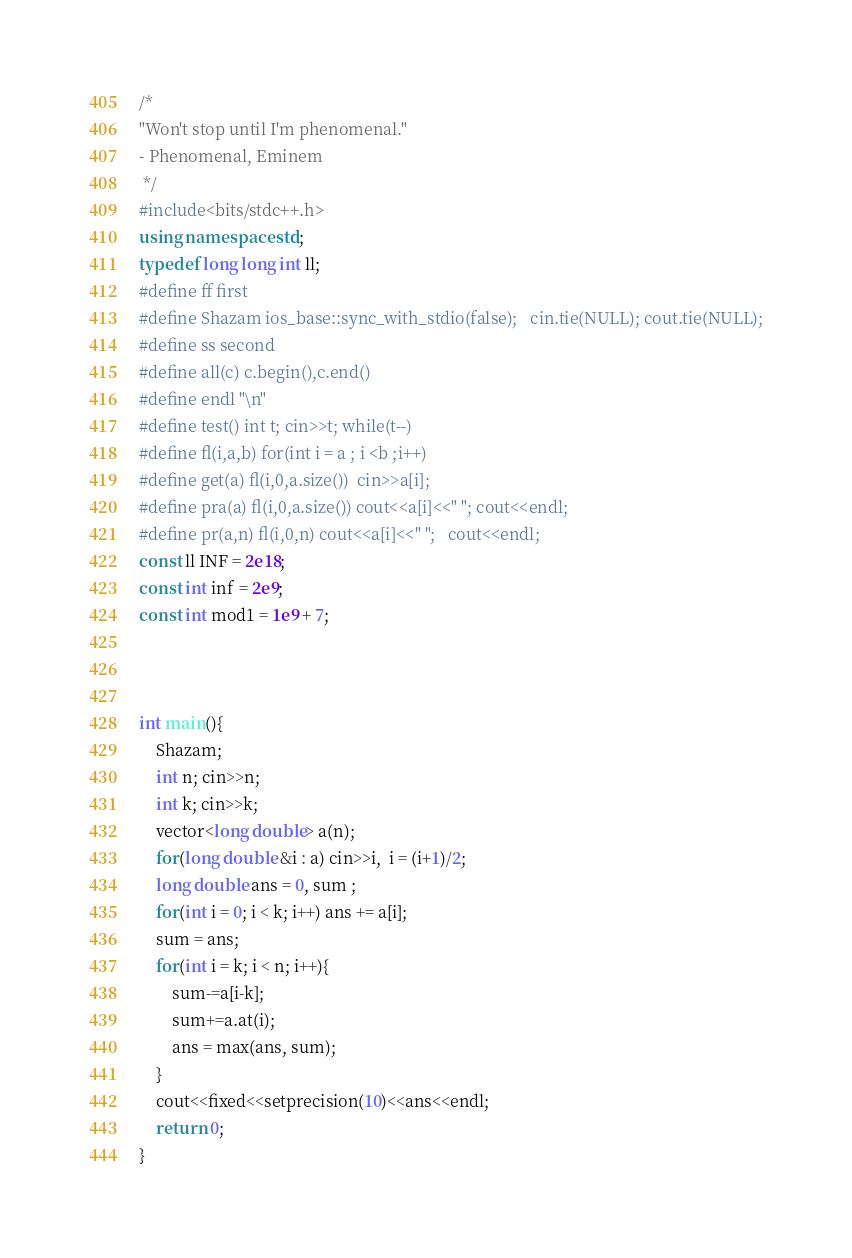Convert code to text. <code><loc_0><loc_0><loc_500><loc_500><_C++_>/*
"Won't stop until I'm phenomenal."
- Phenomenal, Eminem
 */
#include<bits/stdc++.h>
using namespace std;
typedef long long int ll;
#define ff first
#define Shazam ios_base::sync_with_stdio(false);   cin.tie(NULL); cout.tie(NULL);
#define ss second
#define all(c) c.begin(),c.end()
#define endl "\n"
#define test() int t; cin>>t; while(t--)
#define fl(i,a,b) for(int i = a ; i <b ;i++)
#define get(a) fl(i,0,a.size())  cin>>a[i];
#define pra(a) fl(i,0,a.size()) cout<<a[i]<<" ";	cout<<endl;
#define pr(a,n) fl(i,0,n) cout<<a[i]<<" ";	cout<<endl;
const ll INF = 2e18;
const int inf = 2e9;
const int mod1 = 1e9 + 7;



int main(){
    Shazam;
    int n; cin>>n;
    int k; cin>>k;
    vector<long double> a(n);
    for(long double &i : a) cin>>i,  i = (i+1)/2;
    long double ans = 0, sum ;
    for(int i = 0; i < k; i++) ans += a[i];
    sum = ans;
    for(int i = k; i < n; i++){
        sum-=a[i-k];
        sum+=a.at(i);
        ans = max(ans, sum);
    }
    cout<<fixed<<setprecision(10)<<ans<<endl;
    return 0;
}</code> 